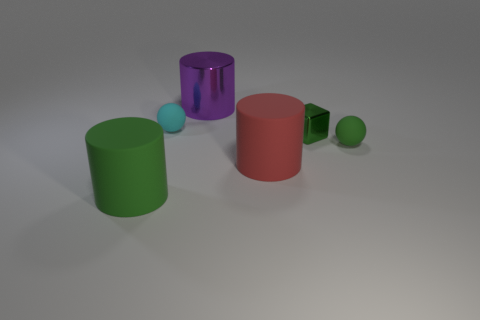Subtract all rubber cylinders. How many cylinders are left? 1 Subtract all red cylinders. How many cylinders are left? 2 Subtract all green cylinders. How many red cubes are left? 0 Add 6 green balls. How many green balls are left? 7 Add 4 big green rubber cylinders. How many big green rubber cylinders exist? 5 Add 2 green metal blocks. How many objects exist? 8 Subtract 1 red cylinders. How many objects are left? 5 Subtract all spheres. How many objects are left? 4 Subtract 2 cylinders. How many cylinders are left? 1 Subtract all blue cylinders. Subtract all red blocks. How many cylinders are left? 3 